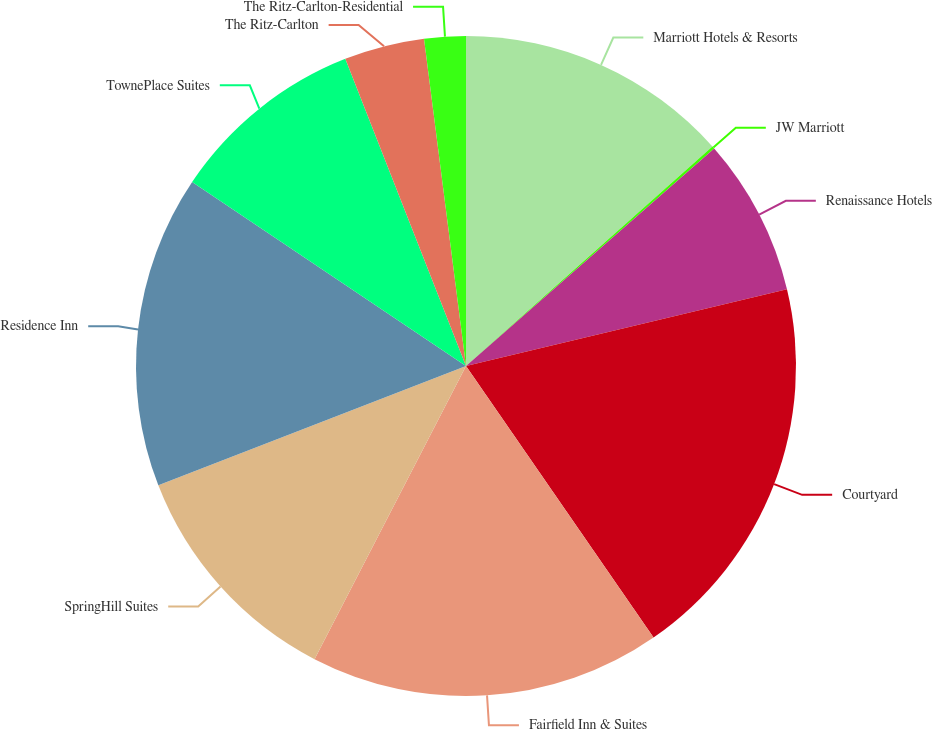<chart> <loc_0><loc_0><loc_500><loc_500><pie_chart><fcel>Marriott Hotels & Resorts<fcel>JW Marriott<fcel>Renaissance Hotels<fcel>Courtyard<fcel>Fairfield Inn & Suites<fcel>SpringHill Suites<fcel>Residence Inn<fcel>TownePlace Suites<fcel>The Ritz-Carlton<fcel>The Ritz-Carlton-Residential<nl><fcel>13.42%<fcel>0.13%<fcel>7.72%<fcel>19.11%<fcel>17.21%<fcel>11.52%<fcel>15.31%<fcel>9.62%<fcel>3.93%<fcel>2.03%<nl></chart> 